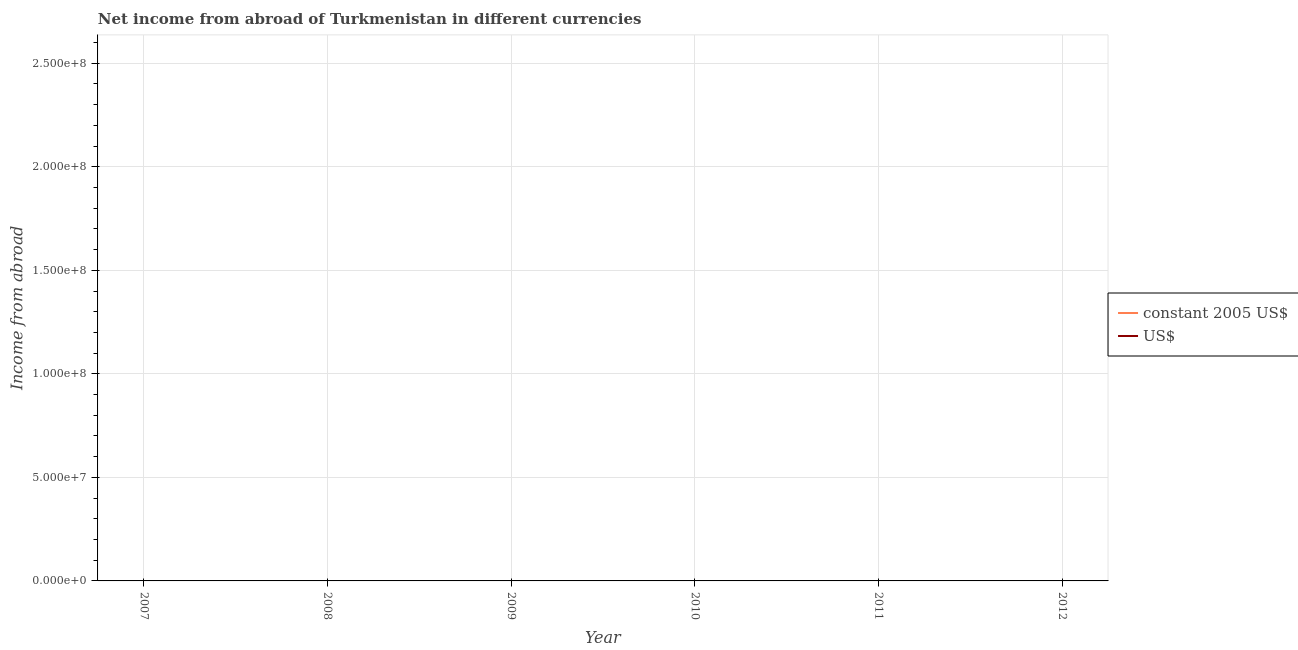How many different coloured lines are there?
Make the answer very short. 0. Does the line corresponding to income from abroad in constant 2005 us$ intersect with the line corresponding to income from abroad in us$?
Offer a terse response. No. Is the number of lines equal to the number of legend labels?
Provide a succinct answer. No. What is the income from abroad in us$ in 2008?
Keep it short and to the point. 0. Across all years, what is the minimum income from abroad in us$?
Your answer should be compact. 0. What is the difference between the income from abroad in constant 2005 us$ in 2012 and the income from abroad in us$ in 2007?
Your answer should be compact. 0. In how many years, is the income from abroad in us$ greater than 240000000 units?
Make the answer very short. 0. In how many years, is the income from abroad in constant 2005 us$ greater than the average income from abroad in constant 2005 us$ taken over all years?
Your response must be concise. 0. Does the income from abroad in constant 2005 us$ monotonically increase over the years?
Your response must be concise. No. Is the income from abroad in constant 2005 us$ strictly less than the income from abroad in us$ over the years?
Provide a short and direct response. Yes. What is the difference between two consecutive major ticks on the Y-axis?
Your response must be concise. 5.00e+07. Are the values on the major ticks of Y-axis written in scientific E-notation?
Your answer should be compact. Yes. Does the graph contain any zero values?
Give a very brief answer. Yes. Does the graph contain grids?
Make the answer very short. Yes. Where does the legend appear in the graph?
Give a very brief answer. Center right. How many legend labels are there?
Keep it short and to the point. 2. What is the title of the graph?
Provide a short and direct response. Net income from abroad of Turkmenistan in different currencies. What is the label or title of the Y-axis?
Your answer should be compact. Income from abroad. What is the Income from abroad in US$ in 2007?
Give a very brief answer. 0. What is the Income from abroad in constant 2005 US$ in 2008?
Make the answer very short. 0. What is the Income from abroad in constant 2005 US$ in 2009?
Your answer should be compact. 0. What is the Income from abroad of US$ in 2010?
Offer a very short reply. 0. What is the total Income from abroad of constant 2005 US$ in the graph?
Your answer should be very brief. 0. What is the average Income from abroad of US$ per year?
Keep it short and to the point. 0. 